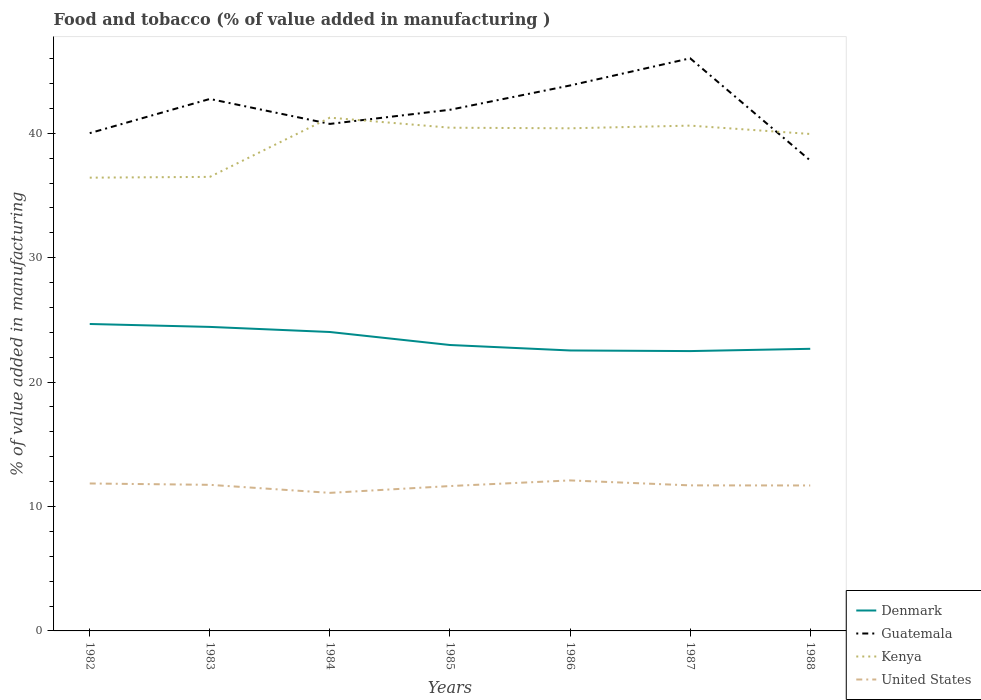How many different coloured lines are there?
Your answer should be very brief. 4. Does the line corresponding to Kenya intersect with the line corresponding to Guatemala?
Your answer should be compact. Yes. Across all years, what is the maximum value added in manufacturing food and tobacco in Kenya?
Give a very brief answer. 36.43. In which year was the value added in manufacturing food and tobacco in Guatemala maximum?
Your answer should be very brief. 1988. What is the total value added in manufacturing food and tobacco in Denmark in the graph?
Your answer should be very brief. 0.05. What is the difference between the highest and the second highest value added in manufacturing food and tobacco in Kenya?
Your answer should be very brief. 4.82. What is the difference between the highest and the lowest value added in manufacturing food and tobacco in United States?
Make the answer very short. 5. Is the value added in manufacturing food and tobacco in Guatemala strictly greater than the value added in manufacturing food and tobacco in Kenya over the years?
Offer a very short reply. No. How many lines are there?
Ensure brevity in your answer.  4. What is the difference between two consecutive major ticks on the Y-axis?
Your answer should be compact. 10. Are the values on the major ticks of Y-axis written in scientific E-notation?
Ensure brevity in your answer.  No. Does the graph contain any zero values?
Keep it short and to the point. No. Does the graph contain grids?
Ensure brevity in your answer.  No. Where does the legend appear in the graph?
Offer a very short reply. Bottom right. How are the legend labels stacked?
Your answer should be compact. Vertical. What is the title of the graph?
Ensure brevity in your answer.  Food and tobacco (% of value added in manufacturing ). Does "Other small states" appear as one of the legend labels in the graph?
Make the answer very short. No. What is the label or title of the X-axis?
Provide a succinct answer. Years. What is the label or title of the Y-axis?
Keep it short and to the point. % of value added in manufacturing. What is the % of value added in manufacturing in Denmark in 1982?
Keep it short and to the point. 24.67. What is the % of value added in manufacturing of Guatemala in 1982?
Give a very brief answer. 40.01. What is the % of value added in manufacturing in Kenya in 1982?
Provide a succinct answer. 36.43. What is the % of value added in manufacturing in United States in 1982?
Provide a succinct answer. 11.85. What is the % of value added in manufacturing of Denmark in 1983?
Your answer should be very brief. 24.44. What is the % of value added in manufacturing of Guatemala in 1983?
Ensure brevity in your answer.  42.76. What is the % of value added in manufacturing in Kenya in 1983?
Give a very brief answer. 36.5. What is the % of value added in manufacturing of United States in 1983?
Ensure brevity in your answer.  11.74. What is the % of value added in manufacturing in Denmark in 1984?
Ensure brevity in your answer.  24.03. What is the % of value added in manufacturing of Guatemala in 1984?
Make the answer very short. 40.75. What is the % of value added in manufacturing of Kenya in 1984?
Provide a short and direct response. 41.26. What is the % of value added in manufacturing in United States in 1984?
Provide a succinct answer. 11.1. What is the % of value added in manufacturing of Denmark in 1985?
Keep it short and to the point. 22.98. What is the % of value added in manufacturing of Guatemala in 1985?
Keep it short and to the point. 41.89. What is the % of value added in manufacturing in Kenya in 1985?
Provide a short and direct response. 40.45. What is the % of value added in manufacturing of United States in 1985?
Offer a terse response. 11.64. What is the % of value added in manufacturing of Denmark in 1986?
Provide a short and direct response. 22.54. What is the % of value added in manufacturing in Guatemala in 1986?
Your response must be concise. 43.84. What is the % of value added in manufacturing in Kenya in 1986?
Give a very brief answer. 40.4. What is the % of value added in manufacturing of United States in 1986?
Your response must be concise. 12.1. What is the % of value added in manufacturing of Denmark in 1987?
Your answer should be compact. 22.49. What is the % of value added in manufacturing of Guatemala in 1987?
Make the answer very short. 46.03. What is the % of value added in manufacturing of Kenya in 1987?
Offer a terse response. 40.62. What is the % of value added in manufacturing of United States in 1987?
Ensure brevity in your answer.  11.7. What is the % of value added in manufacturing of Denmark in 1988?
Offer a terse response. 22.68. What is the % of value added in manufacturing in Guatemala in 1988?
Provide a short and direct response. 37.81. What is the % of value added in manufacturing in Kenya in 1988?
Offer a terse response. 39.94. What is the % of value added in manufacturing in United States in 1988?
Offer a very short reply. 11.69. Across all years, what is the maximum % of value added in manufacturing of Denmark?
Offer a terse response. 24.67. Across all years, what is the maximum % of value added in manufacturing of Guatemala?
Your answer should be very brief. 46.03. Across all years, what is the maximum % of value added in manufacturing of Kenya?
Make the answer very short. 41.26. Across all years, what is the maximum % of value added in manufacturing in United States?
Keep it short and to the point. 12.1. Across all years, what is the minimum % of value added in manufacturing of Denmark?
Offer a very short reply. 22.49. Across all years, what is the minimum % of value added in manufacturing in Guatemala?
Your response must be concise. 37.81. Across all years, what is the minimum % of value added in manufacturing in Kenya?
Offer a terse response. 36.43. Across all years, what is the minimum % of value added in manufacturing in United States?
Your answer should be compact. 11.1. What is the total % of value added in manufacturing in Denmark in the graph?
Your answer should be very brief. 163.83. What is the total % of value added in manufacturing in Guatemala in the graph?
Your answer should be very brief. 293.09. What is the total % of value added in manufacturing in Kenya in the graph?
Give a very brief answer. 275.59. What is the total % of value added in manufacturing in United States in the graph?
Offer a terse response. 81.82. What is the difference between the % of value added in manufacturing of Denmark in 1982 and that in 1983?
Provide a short and direct response. 0.23. What is the difference between the % of value added in manufacturing in Guatemala in 1982 and that in 1983?
Offer a very short reply. -2.75. What is the difference between the % of value added in manufacturing of Kenya in 1982 and that in 1983?
Keep it short and to the point. -0.06. What is the difference between the % of value added in manufacturing of United States in 1982 and that in 1983?
Offer a very short reply. 0.11. What is the difference between the % of value added in manufacturing of Denmark in 1982 and that in 1984?
Your answer should be compact. 0.64. What is the difference between the % of value added in manufacturing in Guatemala in 1982 and that in 1984?
Offer a terse response. -0.74. What is the difference between the % of value added in manufacturing of Kenya in 1982 and that in 1984?
Your response must be concise. -4.82. What is the difference between the % of value added in manufacturing of United States in 1982 and that in 1984?
Offer a very short reply. 0.75. What is the difference between the % of value added in manufacturing of Denmark in 1982 and that in 1985?
Ensure brevity in your answer.  1.69. What is the difference between the % of value added in manufacturing of Guatemala in 1982 and that in 1985?
Offer a terse response. -1.88. What is the difference between the % of value added in manufacturing of Kenya in 1982 and that in 1985?
Offer a very short reply. -4.02. What is the difference between the % of value added in manufacturing in United States in 1982 and that in 1985?
Ensure brevity in your answer.  0.21. What is the difference between the % of value added in manufacturing in Denmark in 1982 and that in 1986?
Your answer should be compact. 2.13. What is the difference between the % of value added in manufacturing in Guatemala in 1982 and that in 1986?
Make the answer very short. -3.83. What is the difference between the % of value added in manufacturing in Kenya in 1982 and that in 1986?
Make the answer very short. -3.97. What is the difference between the % of value added in manufacturing of United States in 1982 and that in 1986?
Ensure brevity in your answer.  -0.25. What is the difference between the % of value added in manufacturing of Denmark in 1982 and that in 1987?
Your answer should be compact. 2.18. What is the difference between the % of value added in manufacturing of Guatemala in 1982 and that in 1987?
Keep it short and to the point. -6.02. What is the difference between the % of value added in manufacturing of Kenya in 1982 and that in 1987?
Make the answer very short. -4.18. What is the difference between the % of value added in manufacturing of United States in 1982 and that in 1987?
Your response must be concise. 0.15. What is the difference between the % of value added in manufacturing of Denmark in 1982 and that in 1988?
Provide a short and direct response. 1.99. What is the difference between the % of value added in manufacturing in Guatemala in 1982 and that in 1988?
Offer a terse response. 2.2. What is the difference between the % of value added in manufacturing in Kenya in 1982 and that in 1988?
Your answer should be very brief. -3.51. What is the difference between the % of value added in manufacturing of United States in 1982 and that in 1988?
Provide a short and direct response. 0.16. What is the difference between the % of value added in manufacturing of Denmark in 1983 and that in 1984?
Ensure brevity in your answer.  0.41. What is the difference between the % of value added in manufacturing in Guatemala in 1983 and that in 1984?
Your response must be concise. 2.01. What is the difference between the % of value added in manufacturing of Kenya in 1983 and that in 1984?
Provide a short and direct response. -4.76. What is the difference between the % of value added in manufacturing of United States in 1983 and that in 1984?
Ensure brevity in your answer.  0.65. What is the difference between the % of value added in manufacturing of Denmark in 1983 and that in 1985?
Give a very brief answer. 1.45. What is the difference between the % of value added in manufacturing of Guatemala in 1983 and that in 1985?
Your answer should be compact. 0.87. What is the difference between the % of value added in manufacturing of Kenya in 1983 and that in 1985?
Offer a terse response. -3.95. What is the difference between the % of value added in manufacturing of United States in 1983 and that in 1985?
Provide a short and direct response. 0.1. What is the difference between the % of value added in manufacturing of Denmark in 1983 and that in 1986?
Your response must be concise. 1.89. What is the difference between the % of value added in manufacturing of Guatemala in 1983 and that in 1986?
Your answer should be compact. -1.08. What is the difference between the % of value added in manufacturing in Kenya in 1983 and that in 1986?
Provide a succinct answer. -3.91. What is the difference between the % of value added in manufacturing of United States in 1983 and that in 1986?
Provide a succinct answer. -0.36. What is the difference between the % of value added in manufacturing in Denmark in 1983 and that in 1987?
Keep it short and to the point. 1.94. What is the difference between the % of value added in manufacturing in Guatemala in 1983 and that in 1987?
Your response must be concise. -3.27. What is the difference between the % of value added in manufacturing of Kenya in 1983 and that in 1987?
Offer a terse response. -4.12. What is the difference between the % of value added in manufacturing in United States in 1983 and that in 1987?
Provide a succinct answer. 0.04. What is the difference between the % of value added in manufacturing of Denmark in 1983 and that in 1988?
Offer a terse response. 1.76. What is the difference between the % of value added in manufacturing in Guatemala in 1983 and that in 1988?
Offer a terse response. 4.95. What is the difference between the % of value added in manufacturing of Kenya in 1983 and that in 1988?
Your answer should be very brief. -3.45. What is the difference between the % of value added in manufacturing of United States in 1983 and that in 1988?
Provide a succinct answer. 0.05. What is the difference between the % of value added in manufacturing of Denmark in 1984 and that in 1985?
Offer a terse response. 1.05. What is the difference between the % of value added in manufacturing of Guatemala in 1984 and that in 1985?
Offer a very short reply. -1.14. What is the difference between the % of value added in manufacturing of Kenya in 1984 and that in 1985?
Offer a very short reply. 0.81. What is the difference between the % of value added in manufacturing in United States in 1984 and that in 1985?
Your answer should be very brief. -0.55. What is the difference between the % of value added in manufacturing in Denmark in 1984 and that in 1986?
Make the answer very short. 1.49. What is the difference between the % of value added in manufacturing of Guatemala in 1984 and that in 1986?
Keep it short and to the point. -3.09. What is the difference between the % of value added in manufacturing in Kenya in 1984 and that in 1986?
Your answer should be compact. 0.86. What is the difference between the % of value added in manufacturing of United States in 1984 and that in 1986?
Offer a very short reply. -1. What is the difference between the % of value added in manufacturing in Denmark in 1984 and that in 1987?
Provide a short and direct response. 1.53. What is the difference between the % of value added in manufacturing in Guatemala in 1984 and that in 1987?
Keep it short and to the point. -5.27. What is the difference between the % of value added in manufacturing in Kenya in 1984 and that in 1987?
Provide a succinct answer. 0.64. What is the difference between the % of value added in manufacturing in United States in 1984 and that in 1987?
Your response must be concise. -0.6. What is the difference between the % of value added in manufacturing in Denmark in 1984 and that in 1988?
Keep it short and to the point. 1.35. What is the difference between the % of value added in manufacturing in Guatemala in 1984 and that in 1988?
Provide a succinct answer. 2.94. What is the difference between the % of value added in manufacturing of Kenya in 1984 and that in 1988?
Keep it short and to the point. 1.31. What is the difference between the % of value added in manufacturing of United States in 1984 and that in 1988?
Ensure brevity in your answer.  -0.59. What is the difference between the % of value added in manufacturing in Denmark in 1985 and that in 1986?
Give a very brief answer. 0.44. What is the difference between the % of value added in manufacturing in Guatemala in 1985 and that in 1986?
Make the answer very short. -1.95. What is the difference between the % of value added in manufacturing in Kenya in 1985 and that in 1986?
Keep it short and to the point. 0.05. What is the difference between the % of value added in manufacturing in United States in 1985 and that in 1986?
Provide a succinct answer. -0.45. What is the difference between the % of value added in manufacturing of Denmark in 1985 and that in 1987?
Your answer should be very brief. 0.49. What is the difference between the % of value added in manufacturing of Guatemala in 1985 and that in 1987?
Offer a very short reply. -4.14. What is the difference between the % of value added in manufacturing of Kenya in 1985 and that in 1987?
Offer a terse response. -0.17. What is the difference between the % of value added in manufacturing of United States in 1985 and that in 1987?
Keep it short and to the point. -0.05. What is the difference between the % of value added in manufacturing in Denmark in 1985 and that in 1988?
Offer a terse response. 0.31. What is the difference between the % of value added in manufacturing of Guatemala in 1985 and that in 1988?
Offer a terse response. 4.08. What is the difference between the % of value added in manufacturing of Kenya in 1985 and that in 1988?
Offer a terse response. 0.5. What is the difference between the % of value added in manufacturing in United States in 1985 and that in 1988?
Offer a very short reply. -0.05. What is the difference between the % of value added in manufacturing of Denmark in 1986 and that in 1987?
Provide a short and direct response. 0.05. What is the difference between the % of value added in manufacturing in Guatemala in 1986 and that in 1987?
Your response must be concise. -2.18. What is the difference between the % of value added in manufacturing of Kenya in 1986 and that in 1987?
Your response must be concise. -0.22. What is the difference between the % of value added in manufacturing in United States in 1986 and that in 1987?
Keep it short and to the point. 0.4. What is the difference between the % of value added in manufacturing in Denmark in 1986 and that in 1988?
Your answer should be very brief. -0.13. What is the difference between the % of value added in manufacturing in Guatemala in 1986 and that in 1988?
Give a very brief answer. 6.03. What is the difference between the % of value added in manufacturing of Kenya in 1986 and that in 1988?
Ensure brevity in your answer.  0.46. What is the difference between the % of value added in manufacturing in United States in 1986 and that in 1988?
Your response must be concise. 0.41. What is the difference between the % of value added in manufacturing in Denmark in 1987 and that in 1988?
Give a very brief answer. -0.18. What is the difference between the % of value added in manufacturing of Guatemala in 1987 and that in 1988?
Make the answer very short. 8.22. What is the difference between the % of value added in manufacturing in Kenya in 1987 and that in 1988?
Your response must be concise. 0.67. What is the difference between the % of value added in manufacturing in United States in 1987 and that in 1988?
Your answer should be compact. 0.01. What is the difference between the % of value added in manufacturing in Denmark in 1982 and the % of value added in manufacturing in Guatemala in 1983?
Your response must be concise. -18.09. What is the difference between the % of value added in manufacturing of Denmark in 1982 and the % of value added in manufacturing of Kenya in 1983?
Make the answer very short. -11.82. What is the difference between the % of value added in manufacturing in Denmark in 1982 and the % of value added in manufacturing in United States in 1983?
Provide a succinct answer. 12.93. What is the difference between the % of value added in manufacturing in Guatemala in 1982 and the % of value added in manufacturing in Kenya in 1983?
Keep it short and to the point. 3.52. What is the difference between the % of value added in manufacturing of Guatemala in 1982 and the % of value added in manufacturing of United States in 1983?
Provide a succinct answer. 28.27. What is the difference between the % of value added in manufacturing of Kenya in 1982 and the % of value added in manufacturing of United States in 1983?
Ensure brevity in your answer.  24.69. What is the difference between the % of value added in manufacturing of Denmark in 1982 and the % of value added in manufacturing of Guatemala in 1984?
Offer a very short reply. -16.08. What is the difference between the % of value added in manufacturing in Denmark in 1982 and the % of value added in manufacturing in Kenya in 1984?
Keep it short and to the point. -16.59. What is the difference between the % of value added in manufacturing of Denmark in 1982 and the % of value added in manufacturing of United States in 1984?
Your answer should be very brief. 13.57. What is the difference between the % of value added in manufacturing in Guatemala in 1982 and the % of value added in manufacturing in Kenya in 1984?
Ensure brevity in your answer.  -1.24. What is the difference between the % of value added in manufacturing in Guatemala in 1982 and the % of value added in manufacturing in United States in 1984?
Keep it short and to the point. 28.91. What is the difference between the % of value added in manufacturing of Kenya in 1982 and the % of value added in manufacturing of United States in 1984?
Provide a short and direct response. 25.34. What is the difference between the % of value added in manufacturing in Denmark in 1982 and the % of value added in manufacturing in Guatemala in 1985?
Offer a very short reply. -17.22. What is the difference between the % of value added in manufacturing in Denmark in 1982 and the % of value added in manufacturing in Kenya in 1985?
Your response must be concise. -15.78. What is the difference between the % of value added in manufacturing in Denmark in 1982 and the % of value added in manufacturing in United States in 1985?
Offer a terse response. 13.03. What is the difference between the % of value added in manufacturing in Guatemala in 1982 and the % of value added in manufacturing in Kenya in 1985?
Ensure brevity in your answer.  -0.44. What is the difference between the % of value added in manufacturing of Guatemala in 1982 and the % of value added in manufacturing of United States in 1985?
Ensure brevity in your answer.  28.37. What is the difference between the % of value added in manufacturing of Kenya in 1982 and the % of value added in manufacturing of United States in 1985?
Make the answer very short. 24.79. What is the difference between the % of value added in manufacturing of Denmark in 1982 and the % of value added in manufacturing of Guatemala in 1986?
Your answer should be very brief. -19.17. What is the difference between the % of value added in manufacturing of Denmark in 1982 and the % of value added in manufacturing of Kenya in 1986?
Your response must be concise. -15.73. What is the difference between the % of value added in manufacturing of Denmark in 1982 and the % of value added in manufacturing of United States in 1986?
Your answer should be very brief. 12.57. What is the difference between the % of value added in manufacturing of Guatemala in 1982 and the % of value added in manufacturing of Kenya in 1986?
Provide a succinct answer. -0.39. What is the difference between the % of value added in manufacturing of Guatemala in 1982 and the % of value added in manufacturing of United States in 1986?
Ensure brevity in your answer.  27.91. What is the difference between the % of value added in manufacturing in Kenya in 1982 and the % of value added in manufacturing in United States in 1986?
Give a very brief answer. 24.33. What is the difference between the % of value added in manufacturing in Denmark in 1982 and the % of value added in manufacturing in Guatemala in 1987?
Your answer should be very brief. -21.36. What is the difference between the % of value added in manufacturing in Denmark in 1982 and the % of value added in manufacturing in Kenya in 1987?
Ensure brevity in your answer.  -15.95. What is the difference between the % of value added in manufacturing of Denmark in 1982 and the % of value added in manufacturing of United States in 1987?
Provide a succinct answer. 12.97. What is the difference between the % of value added in manufacturing in Guatemala in 1982 and the % of value added in manufacturing in Kenya in 1987?
Offer a terse response. -0.6. What is the difference between the % of value added in manufacturing of Guatemala in 1982 and the % of value added in manufacturing of United States in 1987?
Your answer should be very brief. 28.31. What is the difference between the % of value added in manufacturing in Kenya in 1982 and the % of value added in manufacturing in United States in 1987?
Give a very brief answer. 24.73. What is the difference between the % of value added in manufacturing in Denmark in 1982 and the % of value added in manufacturing in Guatemala in 1988?
Offer a terse response. -13.14. What is the difference between the % of value added in manufacturing of Denmark in 1982 and the % of value added in manufacturing of Kenya in 1988?
Your answer should be very brief. -15.27. What is the difference between the % of value added in manufacturing in Denmark in 1982 and the % of value added in manufacturing in United States in 1988?
Give a very brief answer. 12.98. What is the difference between the % of value added in manufacturing in Guatemala in 1982 and the % of value added in manufacturing in Kenya in 1988?
Ensure brevity in your answer.  0.07. What is the difference between the % of value added in manufacturing in Guatemala in 1982 and the % of value added in manufacturing in United States in 1988?
Your answer should be compact. 28.32. What is the difference between the % of value added in manufacturing in Kenya in 1982 and the % of value added in manufacturing in United States in 1988?
Your answer should be compact. 24.74. What is the difference between the % of value added in manufacturing in Denmark in 1983 and the % of value added in manufacturing in Guatemala in 1984?
Provide a succinct answer. -16.32. What is the difference between the % of value added in manufacturing of Denmark in 1983 and the % of value added in manufacturing of Kenya in 1984?
Offer a very short reply. -16.82. What is the difference between the % of value added in manufacturing in Denmark in 1983 and the % of value added in manufacturing in United States in 1984?
Provide a succinct answer. 13.34. What is the difference between the % of value added in manufacturing in Guatemala in 1983 and the % of value added in manufacturing in Kenya in 1984?
Give a very brief answer. 1.5. What is the difference between the % of value added in manufacturing in Guatemala in 1983 and the % of value added in manufacturing in United States in 1984?
Give a very brief answer. 31.66. What is the difference between the % of value added in manufacturing of Kenya in 1983 and the % of value added in manufacturing of United States in 1984?
Offer a terse response. 25.4. What is the difference between the % of value added in manufacturing in Denmark in 1983 and the % of value added in manufacturing in Guatemala in 1985?
Give a very brief answer. -17.45. What is the difference between the % of value added in manufacturing of Denmark in 1983 and the % of value added in manufacturing of Kenya in 1985?
Provide a short and direct response. -16.01. What is the difference between the % of value added in manufacturing in Denmark in 1983 and the % of value added in manufacturing in United States in 1985?
Offer a very short reply. 12.79. What is the difference between the % of value added in manufacturing of Guatemala in 1983 and the % of value added in manufacturing of Kenya in 1985?
Your response must be concise. 2.31. What is the difference between the % of value added in manufacturing of Guatemala in 1983 and the % of value added in manufacturing of United States in 1985?
Make the answer very short. 31.11. What is the difference between the % of value added in manufacturing of Kenya in 1983 and the % of value added in manufacturing of United States in 1985?
Offer a terse response. 24.85. What is the difference between the % of value added in manufacturing of Denmark in 1983 and the % of value added in manufacturing of Guatemala in 1986?
Make the answer very short. -19.41. What is the difference between the % of value added in manufacturing in Denmark in 1983 and the % of value added in manufacturing in Kenya in 1986?
Your answer should be very brief. -15.96. What is the difference between the % of value added in manufacturing in Denmark in 1983 and the % of value added in manufacturing in United States in 1986?
Make the answer very short. 12.34. What is the difference between the % of value added in manufacturing in Guatemala in 1983 and the % of value added in manufacturing in Kenya in 1986?
Offer a very short reply. 2.36. What is the difference between the % of value added in manufacturing of Guatemala in 1983 and the % of value added in manufacturing of United States in 1986?
Offer a very short reply. 30.66. What is the difference between the % of value added in manufacturing of Kenya in 1983 and the % of value added in manufacturing of United States in 1986?
Keep it short and to the point. 24.4. What is the difference between the % of value added in manufacturing of Denmark in 1983 and the % of value added in manufacturing of Guatemala in 1987?
Offer a very short reply. -21.59. What is the difference between the % of value added in manufacturing in Denmark in 1983 and the % of value added in manufacturing in Kenya in 1987?
Give a very brief answer. -16.18. What is the difference between the % of value added in manufacturing of Denmark in 1983 and the % of value added in manufacturing of United States in 1987?
Offer a very short reply. 12.74. What is the difference between the % of value added in manufacturing of Guatemala in 1983 and the % of value added in manufacturing of Kenya in 1987?
Keep it short and to the point. 2.14. What is the difference between the % of value added in manufacturing in Guatemala in 1983 and the % of value added in manufacturing in United States in 1987?
Give a very brief answer. 31.06. What is the difference between the % of value added in manufacturing in Kenya in 1983 and the % of value added in manufacturing in United States in 1987?
Your answer should be compact. 24.8. What is the difference between the % of value added in manufacturing of Denmark in 1983 and the % of value added in manufacturing of Guatemala in 1988?
Your response must be concise. -13.37. What is the difference between the % of value added in manufacturing in Denmark in 1983 and the % of value added in manufacturing in Kenya in 1988?
Offer a terse response. -15.51. What is the difference between the % of value added in manufacturing of Denmark in 1983 and the % of value added in manufacturing of United States in 1988?
Provide a succinct answer. 12.74. What is the difference between the % of value added in manufacturing in Guatemala in 1983 and the % of value added in manufacturing in Kenya in 1988?
Your answer should be compact. 2.82. What is the difference between the % of value added in manufacturing of Guatemala in 1983 and the % of value added in manufacturing of United States in 1988?
Make the answer very short. 31.07. What is the difference between the % of value added in manufacturing in Kenya in 1983 and the % of value added in manufacturing in United States in 1988?
Provide a short and direct response. 24.8. What is the difference between the % of value added in manufacturing of Denmark in 1984 and the % of value added in manufacturing of Guatemala in 1985?
Give a very brief answer. -17.86. What is the difference between the % of value added in manufacturing of Denmark in 1984 and the % of value added in manufacturing of Kenya in 1985?
Offer a terse response. -16.42. What is the difference between the % of value added in manufacturing of Denmark in 1984 and the % of value added in manufacturing of United States in 1985?
Your answer should be very brief. 12.38. What is the difference between the % of value added in manufacturing in Guatemala in 1984 and the % of value added in manufacturing in Kenya in 1985?
Provide a short and direct response. 0.3. What is the difference between the % of value added in manufacturing of Guatemala in 1984 and the % of value added in manufacturing of United States in 1985?
Give a very brief answer. 29.11. What is the difference between the % of value added in manufacturing of Kenya in 1984 and the % of value added in manufacturing of United States in 1985?
Ensure brevity in your answer.  29.61. What is the difference between the % of value added in manufacturing in Denmark in 1984 and the % of value added in manufacturing in Guatemala in 1986?
Give a very brief answer. -19.81. What is the difference between the % of value added in manufacturing in Denmark in 1984 and the % of value added in manufacturing in Kenya in 1986?
Your answer should be compact. -16.37. What is the difference between the % of value added in manufacturing of Denmark in 1984 and the % of value added in manufacturing of United States in 1986?
Offer a very short reply. 11.93. What is the difference between the % of value added in manufacturing in Guatemala in 1984 and the % of value added in manufacturing in Kenya in 1986?
Give a very brief answer. 0.35. What is the difference between the % of value added in manufacturing in Guatemala in 1984 and the % of value added in manufacturing in United States in 1986?
Your answer should be very brief. 28.65. What is the difference between the % of value added in manufacturing of Kenya in 1984 and the % of value added in manufacturing of United States in 1986?
Your answer should be compact. 29.16. What is the difference between the % of value added in manufacturing in Denmark in 1984 and the % of value added in manufacturing in Guatemala in 1987?
Ensure brevity in your answer.  -22. What is the difference between the % of value added in manufacturing of Denmark in 1984 and the % of value added in manufacturing of Kenya in 1987?
Ensure brevity in your answer.  -16.59. What is the difference between the % of value added in manufacturing in Denmark in 1984 and the % of value added in manufacturing in United States in 1987?
Ensure brevity in your answer.  12.33. What is the difference between the % of value added in manufacturing in Guatemala in 1984 and the % of value added in manufacturing in Kenya in 1987?
Your answer should be compact. 0.14. What is the difference between the % of value added in manufacturing of Guatemala in 1984 and the % of value added in manufacturing of United States in 1987?
Keep it short and to the point. 29.05. What is the difference between the % of value added in manufacturing in Kenya in 1984 and the % of value added in manufacturing in United States in 1987?
Provide a short and direct response. 29.56. What is the difference between the % of value added in manufacturing in Denmark in 1984 and the % of value added in manufacturing in Guatemala in 1988?
Offer a very short reply. -13.78. What is the difference between the % of value added in manufacturing in Denmark in 1984 and the % of value added in manufacturing in Kenya in 1988?
Your answer should be compact. -15.92. What is the difference between the % of value added in manufacturing of Denmark in 1984 and the % of value added in manufacturing of United States in 1988?
Ensure brevity in your answer.  12.34. What is the difference between the % of value added in manufacturing of Guatemala in 1984 and the % of value added in manufacturing of Kenya in 1988?
Offer a terse response. 0.81. What is the difference between the % of value added in manufacturing in Guatemala in 1984 and the % of value added in manufacturing in United States in 1988?
Your response must be concise. 29.06. What is the difference between the % of value added in manufacturing of Kenya in 1984 and the % of value added in manufacturing of United States in 1988?
Your answer should be very brief. 29.56. What is the difference between the % of value added in manufacturing of Denmark in 1985 and the % of value added in manufacturing of Guatemala in 1986?
Offer a terse response. -20.86. What is the difference between the % of value added in manufacturing of Denmark in 1985 and the % of value added in manufacturing of Kenya in 1986?
Provide a succinct answer. -17.42. What is the difference between the % of value added in manufacturing of Denmark in 1985 and the % of value added in manufacturing of United States in 1986?
Offer a terse response. 10.88. What is the difference between the % of value added in manufacturing in Guatemala in 1985 and the % of value added in manufacturing in Kenya in 1986?
Provide a short and direct response. 1.49. What is the difference between the % of value added in manufacturing in Guatemala in 1985 and the % of value added in manufacturing in United States in 1986?
Make the answer very short. 29.79. What is the difference between the % of value added in manufacturing in Kenya in 1985 and the % of value added in manufacturing in United States in 1986?
Offer a terse response. 28.35. What is the difference between the % of value added in manufacturing in Denmark in 1985 and the % of value added in manufacturing in Guatemala in 1987?
Keep it short and to the point. -23.04. What is the difference between the % of value added in manufacturing in Denmark in 1985 and the % of value added in manufacturing in Kenya in 1987?
Keep it short and to the point. -17.63. What is the difference between the % of value added in manufacturing in Denmark in 1985 and the % of value added in manufacturing in United States in 1987?
Your answer should be very brief. 11.28. What is the difference between the % of value added in manufacturing in Guatemala in 1985 and the % of value added in manufacturing in Kenya in 1987?
Your answer should be very brief. 1.27. What is the difference between the % of value added in manufacturing of Guatemala in 1985 and the % of value added in manufacturing of United States in 1987?
Your answer should be compact. 30.19. What is the difference between the % of value added in manufacturing of Kenya in 1985 and the % of value added in manufacturing of United States in 1987?
Offer a very short reply. 28.75. What is the difference between the % of value added in manufacturing of Denmark in 1985 and the % of value added in manufacturing of Guatemala in 1988?
Ensure brevity in your answer.  -14.83. What is the difference between the % of value added in manufacturing in Denmark in 1985 and the % of value added in manufacturing in Kenya in 1988?
Make the answer very short. -16.96. What is the difference between the % of value added in manufacturing of Denmark in 1985 and the % of value added in manufacturing of United States in 1988?
Offer a very short reply. 11.29. What is the difference between the % of value added in manufacturing of Guatemala in 1985 and the % of value added in manufacturing of Kenya in 1988?
Your answer should be very brief. 1.95. What is the difference between the % of value added in manufacturing in Guatemala in 1985 and the % of value added in manufacturing in United States in 1988?
Make the answer very short. 30.2. What is the difference between the % of value added in manufacturing in Kenya in 1985 and the % of value added in manufacturing in United States in 1988?
Keep it short and to the point. 28.76. What is the difference between the % of value added in manufacturing of Denmark in 1986 and the % of value added in manufacturing of Guatemala in 1987?
Your answer should be very brief. -23.48. What is the difference between the % of value added in manufacturing of Denmark in 1986 and the % of value added in manufacturing of Kenya in 1987?
Make the answer very short. -18.07. What is the difference between the % of value added in manufacturing of Denmark in 1986 and the % of value added in manufacturing of United States in 1987?
Offer a terse response. 10.84. What is the difference between the % of value added in manufacturing of Guatemala in 1986 and the % of value added in manufacturing of Kenya in 1987?
Your answer should be very brief. 3.23. What is the difference between the % of value added in manufacturing of Guatemala in 1986 and the % of value added in manufacturing of United States in 1987?
Offer a very short reply. 32.14. What is the difference between the % of value added in manufacturing in Kenya in 1986 and the % of value added in manufacturing in United States in 1987?
Provide a short and direct response. 28.7. What is the difference between the % of value added in manufacturing in Denmark in 1986 and the % of value added in manufacturing in Guatemala in 1988?
Provide a succinct answer. -15.27. What is the difference between the % of value added in manufacturing of Denmark in 1986 and the % of value added in manufacturing of Kenya in 1988?
Your answer should be very brief. -17.4. What is the difference between the % of value added in manufacturing in Denmark in 1986 and the % of value added in manufacturing in United States in 1988?
Your answer should be very brief. 10.85. What is the difference between the % of value added in manufacturing of Guatemala in 1986 and the % of value added in manufacturing of Kenya in 1988?
Ensure brevity in your answer.  3.9. What is the difference between the % of value added in manufacturing of Guatemala in 1986 and the % of value added in manufacturing of United States in 1988?
Keep it short and to the point. 32.15. What is the difference between the % of value added in manufacturing of Kenya in 1986 and the % of value added in manufacturing of United States in 1988?
Your response must be concise. 28.71. What is the difference between the % of value added in manufacturing of Denmark in 1987 and the % of value added in manufacturing of Guatemala in 1988?
Offer a very short reply. -15.32. What is the difference between the % of value added in manufacturing of Denmark in 1987 and the % of value added in manufacturing of Kenya in 1988?
Your answer should be very brief. -17.45. What is the difference between the % of value added in manufacturing of Denmark in 1987 and the % of value added in manufacturing of United States in 1988?
Make the answer very short. 10.8. What is the difference between the % of value added in manufacturing of Guatemala in 1987 and the % of value added in manufacturing of Kenya in 1988?
Your answer should be compact. 6.08. What is the difference between the % of value added in manufacturing of Guatemala in 1987 and the % of value added in manufacturing of United States in 1988?
Ensure brevity in your answer.  34.33. What is the difference between the % of value added in manufacturing of Kenya in 1987 and the % of value added in manufacturing of United States in 1988?
Offer a terse response. 28.92. What is the average % of value added in manufacturing of Denmark per year?
Ensure brevity in your answer.  23.4. What is the average % of value added in manufacturing in Guatemala per year?
Offer a very short reply. 41.87. What is the average % of value added in manufacturing in Kenya per year?
Give a very brief answer. 39.37. What is the average % of value added in manufacturing in United States per year?
Your answer should be very brief. 11.69. In the year 1982, what is the difference between the % of value added in manufacturing in Denmark and % of value added in manufacturing in Guatemala?
Provide a succinct answer. -15.34. In the year 1982, what is the difference between the % of value added in manufacturing in Denmark and % of value added in manufacturing in Kenya?
Provide a short and direct response. -11.76. In the year 1982, what is the difference between the % of value added in manufacturing in Denmark and % of value added in manufacturing in United States?
Ensure brevity in your answer.  12.82. In the year 1982, what is the difference between the % of value added in manufacturing in Guatemala and % of value added in manufacturing in Kenya?
Offer a very short reply. 3.58. In the year 1982, what is the difference between the % of value added in manufacturing of Guatemala and % of value added in manufacturing of United States?
Offer a terse response. 28.16. In the year 1982, what is the difference between the % of value added in manufacturing of Kenya and % of value added in manufacturing of United States?
Provide a succinct answer. 24.58. In the year 1983, what is the difference between the % of value added in manufacturing in Denmark and % of value added in manufacturing in Guatemala?
Your answer should be very brief. -18.32. In the year 1983, what is the difference between the % of value added in manufacturing in Denmark and % of value added in manufacturing in Kenya?
Provide a short and direct response. -12.06. In the year 1983, what is the difference between the % of value added in manufacturing of Denmark and % of value added in manufacturing of United States?
Your response must be concise. 12.69. In the year 1983, what is the difference between the % of value added in manufacturing in Guatemala and % of value added in manufacturing in Kenya?
Ensure brevity in your answer.  6.26. In the year 1983, what is the difference between the % of value added in manufacturing in Guatemala and % of value added in manufacturing in United States?
Your answer should be compact. 31.02. In the year 1983, what is the difference between the % of value added in manufacturing of Kenya and % of value added in manufacturing of United States?
Ensure brevity in your answer.  24.75. In the year 1984, what is the difference between the % of value added in manufacturing in Denmark and % of value added in manufacturing in Guatemala?
Provide a short and direct response. -16.73. In the year 1984, what is the difference between the % of value added in manufacturing of Denmark and % of value added in manufacturing of Kenya?
Your answer should be very brief. -17.23. In the year 1984, what is the difference between the % of value added in manufacturing in Denmark and % of value added in manufacturing in United States?
Your response must be concise. 12.93. In the year 1984, what is the difference between the % of value added in manufacturing of Guatemala and % of value added in manufacturing of Kenya?
Provide a succinct answer. -0.5. In the year 1984, what is the difference between the % of value added in manufacturing of Guatemala and % of value added in manufacturing of United States?
Keep it short and to the point. 29.66. In the year 1984, what is the difference between the % of value added in manufacturing in Kenya and % of value added in manufacturing in United States?
Provide a short and direct response. 30.16. In the year 1985, what is the difference between the % of value added in manufacturing of Denmark and % of value added in manufacturing of Guatemala?
Your answer should be compact. -18.91. In the year 1985, what is the difference between the % of value added in manufacturing of Denmark and % of value added in manufacturing of Kenya?
Offer a very short reply. -17.47. In the year 1985, what is the difference between the % of value added in manufacturing of Denmark and % of value added in manufacturing of United States?
Your answer should be compact. 11.34. In the year 1985, what is the difference between the % of value added in manufacturing of Guatemala and % of value added in manufacturing of Kenya?
Offer a terse response. 1.44. In the year 1985, what is the difference between the % of value added in manufacturing in Guatemala and % of value added in manufacturing in United States?
Keep it short and to the point. 30.24. In the year 1985, what is the difference between the % of value added in manufacturing in Kenya and % of value added in manufacturing in United States?
Provide a succinct answer. 28.8. In the year 1986, what is the difference between the % of value added in manufacturing in Denmark and % of value added in manufacturing in Guatemala?
Offer a terse response. -21.3. In the year 1986, what is the difference between the % of value added in manufacturing in Denmark and % of value added in manufacturing in Kenya?
Give a very brief answer. -17.86. In the year 1986, what is the difference between the % of value added in manufacturing of Denmark and % of value added in manufacturing of United States?
Give a very brief answer. 10.44. In the year 1986, what is the difference between the % of value added in manufacturing of Guatemala and % of value added in manufacturing of Kenya?
Provide a short and direct response. 3.44. In the year 1986, what is the difference between the % of value added in manufacturing of Guatemala and % of value added in manufacturing of United States?
Make the answer very short. 31.74. In the year 1986, what is the difference between the % of value added in manufacturing in Kenya and % of value added in manufacturing in United States?
Your answer should be very brief. 28.3. In the year 1987, what is the difference between the % of value added in manufacturing in Denmark and % of value added in manufacturing in Guatemala?
Offer a terse response. -23.53. In the year 1987, what is the difference between the % of value added in manufacturing of Denmark and % of value added in manufacturing of Kenya?
Offer a terse response. -18.12. In the year 1987, what is the difference between the % of value added in manufacturing of Denmark and % of value added in manufacturing of United States?
Ensure brevity in your answer.  10.79. In the year 1987, what is the difference between the % of value added in manufacturing in Guatemala and % of value added in manufacturing in Kenya?
Your answer should be very brief. 5.41. In the year 1987, what is the difference between the % of value added in manufacturing in Guatemala and % of value added in manufacturing in United States?
Offer a very short reply. 34.33. In the year 1987, what is the difference between the % of value added in manufacturing in Kenya and % of value added in manufacturing in United States?
Your response must be concise. 28.92. In the year 1988, what is the difference between the % of value added in manufacturing of Denmark and % of value added in manufacturing of Guatemala?
Your answer should be compact. -15.13. In the year 1988, what is the difference between the % of value added in manufacturing of Denmark and % of value added in manufacturing of Kenya?
Give a very brief answer. -17.27. In the year 1988, what is the difference between the % of value added in manufacturing in Denmark and % of value added in manufacturing in United States?
Your response must be concise. 10.98. In the year 1988, what is the difference between the % of value added in manufacturing in Guatemala and % of value added in manufacturing in Kenya?
Your answer should be very brief. -2.13. In the year 1988, what is the difference between the % of value added in manufacturing of Guatemala and % of value added in manufacturing of United States?
Your answer should be compact. 26.12. In the year 1988, what is the difference between the % of value added in manufacturing of Kenya and % of value added in manufacturing of United States?
Your response must be concise. 28.25. What is the ratio of the % of value added in manufacturing of Denmark in 1982 to that in 1983?
Keep it short and to the point. 1.01. What is the ratio of the % of value added in manufacturing of Guatemala in 1982 to that in 1983?
Keep it short and to the point. 0.94. What is the ratio of the % of value added in manufacturing in United States in 1982 to that in 1983?
Offer a terse response. 1.01. What is the ratio of the % of value added in manufacturing in Denmark in 1982 to that in 1984?
Your answer should be very brief. 1.03. What is the ratio of the % of value added in manufacturing of Guatemala in 1982 to that in 1984?
Give a very brief answer. 0.98. What is the ratio of the % of value added in manufacturing in Kenya in 1982 to that in 1984?
Make the answer very short. 0.88. What is the ratio of the % of value added in manufacturing of United States in 1982 to that in 1984?
Keep it short and to the point. 1.07. What is the ratio of the % of value added in manufacturing of Denmark in 1982 to that in 1985?
Ensure brevity in your answer.  1.07. What is the ratio of the % of value added in manufacturing of Guatemala in 1982 to that in 1985?
Your answer should be very brief. 0.96. What is the ratio of the % of value added in manufacturing in Kenya in 1982 to that in 1985?
Provide a short and direct response. 0.9. What is the ratio of the % of value added in manufacturing in United States in 1982 to that in 1985?
Make the answer very short. 1.02. What is the ratio of the % of value added in manufacturing of Denmark in 1982 to that in 1986?
Your answer should be compact. 1.09. What is the ratio of the % of value added in manufacturing in Guatemala in 1982 to that in 1986?
Ensure brevity in your answer.  0.91. What is the ratio of the % of value added in manufacturing in Kenya in 1982 to that in 1986?
Provide a short and direct response. 0.9. What is the ratio of the % of value added in manufacturing of United States in 1982 to that in 1986?
Make the answer very short. 0.98. What is the ratio of the % of value added in manufacturing in Denmark in 1982 to that in 1987?
Provide a succinct answer. 1.1. What is the ratio of the % of value added in manufacturing in Guatemala in 1982 to that in 1987?
Give a very brief answer. 0.87. What is the ratio of the % of value added in manufacturing of Kenya in 1982 to that in 1987?
Provide a short and direct response. 0.9. What is the ratio of the % of value added in manufacturing of United States in 1982 to that in 1987?
Your answer should be very brief. 1.01. What is the ratio of the % of value added in manufacturing in Denmark in 1982 to that in 1988?
Your answer should be compact. 1.09. What is the ratio of the % of value added in manufacturing of Guatemala in 1982 to that in 1988?
Make the answer very short. 1.06. What is the ratio of the % of value added in manufacturing in Kenya in 1982 to that in 1988?
Keep it short and to the point. 0.91. What is the ratio of the % of value added in manufacturing in United States in 1982 to that in 1988?
Provide a short and direct response. 1.01. What is the ratio of the % of value added in manufacturing in Denmark in 1983 to that in 1984?
Ensure brevity in your answer.  1.02. What is the ratio of the % of value added in manufacturing in Guatemala in 1983 to that in 1984?
Your response must be concise. 1.05. What is the ratio of the % of value added in manufacturing of Kenya in 1983 to that in 1984?
Give a very brief answer. 0.88. What is the ratio of the % of value added in manufacturing in United States in 1983 to that in 1984?
Provide a succinct answer. 1.06. What is the ratio of the % of value added in manufacturing in Denmark in 1983 to that in 1985?
Your answer should be compact. 1.06. What is the ratio of the % of value added in manufacturing of Guatemala in 1983 to that in 1985?
Make the answer very short. 1.02. What is the ratio of the % of value added in manufacturing of Kenya in 1983 to that in 1985?
Keep it short and to the point. 0.9. What is the ratio of the % of value added in manufacturing of United States in 1983 to that in 1985?
Provide a succinct answer. 1.01. What is the ratio of the % of value added in manufacturing of Denmark in 1983 to that in 1986?
Make the answer very short. 1.08. What is the ratio of the % of value added in manufacturing of Guatemala in 1983 to that in 1986?
Provide a succinct answer. 0.98. What is the ratio of the % of value added in manufacturing in Kenya in 1983 to that in 1986?
Provide a short and direct response. 0.9. What is the ratio of the % of value added in manufacturing in United States in 1983 to that in 1986?
Your response must be concise. 0.97. What is the ratio of the % of value added in manufacturing in Denmark in 1983 to that in 1987?
Give a very brief answer. 1.09. What is the ratio of the % of value added in manufacturing in Guatemala in 1983 to that in 1987?
Keep it short and to the point. 0.93. What is the ratio of the % of value added in manufacturing in Kenya in 1983 to that in 1987?
Give a very brief answer. 0.9. What is the ratio of the % of value added in manufacturing of United States in 1983 to that in 1987?
Offer a terse response. 1. What is the ratio of the % of value added in manufacturing of Denmark in 1983 to that in 1988?
Your response must be concise. 1.08. What is the ratio of the % of value added in manufacturing of Guatemala in 1983 to that in 1988?
Keep it short and to the point. 1.13. What is the ratio of the % of value added in manufacturing of Kenya in 1983 to that in 1988?
Offer a terse response. 0.91. What is the ratio of the % of value added in manufacturing in United States in 1983 to that in 1988?
Make the answer very short. 1. What is the ratio of the % of value added in manufacturing in Denmark in 1984 to that in 1985?
Your answer should be compact. 1.05. What is the ratio of the % of value added in manufacturing of Guatemala in 1984 to that in 1985?
Ensure brevity in your answer.  0.97. What is the ratio of the % of value added in manufacturing of United States in 1984 to that in 1985?
Provide a short and direct response. 0.95. What is the ratio of the % of value added in manufacturing in Denmark in 1984 to that in 1986?
Make the answer very short. 1.07. What is the ratio of the % of value added in manufacturing of Guatemala in 1984 to that in 1986?
Ensure brevity in your answer.  0.93. What is the ratio of the % of value added in manufacturing in Kenya in 1984 to that in 1986?
Offer a very short reply. 1.02. What is the ratio of the % of value added in manufacturing in United States in 1984 to that in 1986?
Keep it short and to the point. 0.92. What is the ratio of the % of value added in manufacturing in Denmark in 1984 to that in 1987?
Provide a short and direct response. 1.07. What is the ratio of the % of value added in manufacturing in Guatemala in 1984 to that in 1987?
Your answer should be very brief. 0.89. What is the ratio of the % of value added in manufacturing of Kenya in 1984 to that in 1987?
Make the answer very short. 1.02. What is the ratio of the % of value added in manufacturing of United States in 1984 to that in 1987?
Ensure brevity in your answer.  0.95. What is the ratio of the % of value added in manufacturing of Denmark in 1984 to that in 1988?
Give a very brief answer. 1.06. What is the ratio of the % of value added in manufacturing of Guatemala in 1984 to that in 1988?
Your answer should be very brief. 1.08. What is the ratio of the % of value added in manufacturing of Kenya in 1984 to that in 1988?
Ensure brevity in your answer.  1.03. What is the ratio of the % of value added in manufacturing of United States in 1984 to that in 1988?
Keep it short and to the point. 0.95. What is the ratio of the % of value added in manufacturing in Denmark in 1985 to that in 1986?
Your response must be concise. 1.02. What is the ratio of the % of value added in manufacturing in Guatemala in 1985 to that in 1986?
Ensure brevity in your answer.  0.96. What is the ratio of the % of value added in manufacturing in United States in 1985 to that in 1986?
Your answer should be compact. 0.96. What is the ratio of the % of value added in manufacturing of Denmark in 1985 to that in 1987?
Give a very brief answer. 1.02. What is the ratio of the % of value added in manufacturing of Guatemala in 1985 to that in 1987?
Offer a very short reply. 0.91. What is the ratio of the % of value added in manufacturing of Denmark in 1985 to that in 1988?
Provide a short and direct response. 1.01. What is the ratio of the % of value added in manufacturing of Guatemala in 1985 to that in 1988?
Keep it short and to the point. 1.11. What is the ratio of the % of value added in manufacturing of Kenya in 1985 to that in 1988?
Provide a short and direct response. 1.01. What is the ratio of the % of value added in manufacturing of Guatemala in 1986 to that in 1987?
Your response must be concise. 0.95. What is the ratio of the % of value added in manufacturing of Kenya in 1986 to that in 1987?
Provide a succinct answer. 0.99. What is the ratio of the % of value added in manufacturing of United States in 1986 to that in 1987?
Your answer should be compact. 1.03. What is the ratio of the % of value added in manufacturing of Denmark in 1986 to that in 1988?
Give a very brief answer. 0.99. What is the ratio of the % of value added in manufacturing in Guatemala in 1986 to that in 1988?
Keep it short and to the point. 1.16. What is the ratio of the % of value added in manufacturing in Kenya in 1986 to that in 1988?
Offer a terse response. 1.01. What is the ratio of the % of value added in manufacturing in United States in 1986 to that in 1988?
Offer a very short reply. 1.03. What is the ratio of the % of value added in manufacturing in Denmark in 1987 to that in 1988?
Provide a short and direct response. 0.99. What is the ratio of the % of value added in manufacturing of Guatemala in 1987 to that in 1988?
Give a very brief answer. 1.22. What is the ratio of the % of value added in manufacturing of Kenya in 1987 to that in 1988?
Provide a short and direct response. 1.02. What is the difference between the highest and the second highest % of value added in manufacturing in Denmark?
Offer a very short reply. 0.23. What is the difference between the highest and the second highest % of value added in manufacturing in Guatemala?
Your response must be concise. 2.18. What is the difference between the highest and the second highest % of value added in manufacturing of Kenya?
Make the answer very short. 0.64. What is the difference between the highest and the second highest % of value added in manufacturing of United States?
Offer a very short reply. 0.25. What is the difference between the highest and the lowest % of value added in manufacturing of Denmark?
Offer a terse response. 2.18. What is the difference between the highest and the lowest % of value added in manufacturing in Guatemala?
Provide a short and direct response. 8.22. What is the difference between the highest and the lowest % of value added in manufacturing in Kenya?
Your response must be concise. 4.82. What is the difference between the highest and the lowest % of value added in manufacturing in United States?
Your response must be concise. 1. 